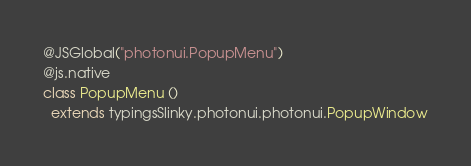Convert code to text. <code><loc_0><loc_0><loc_500><loc_500><_Scala_>@JSGlobal("photonui.PopupMenu")
@js.native
class PopupMenu ()
  extends typingsSlinky.photonui.photonui.PopupWindow
</code> 